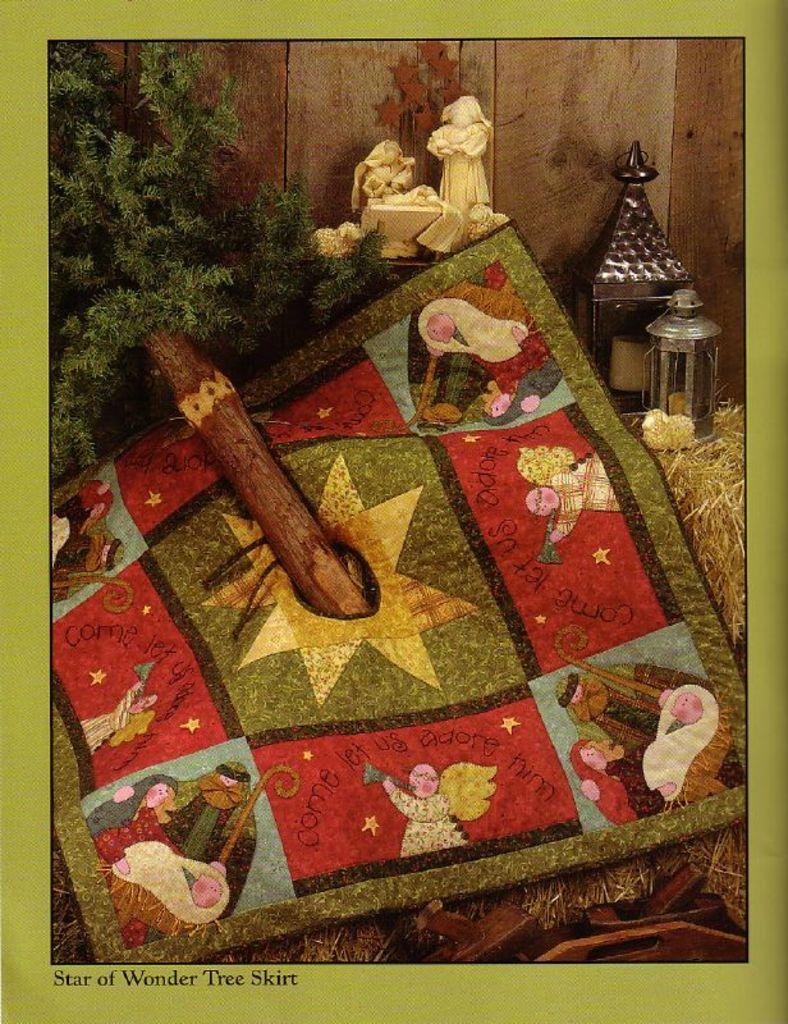Please provide a concise description of this image. The picture consists of dry grass, cloth, Christmas tree and sculptures. In the background it is wooden wall. The picture has green border. 